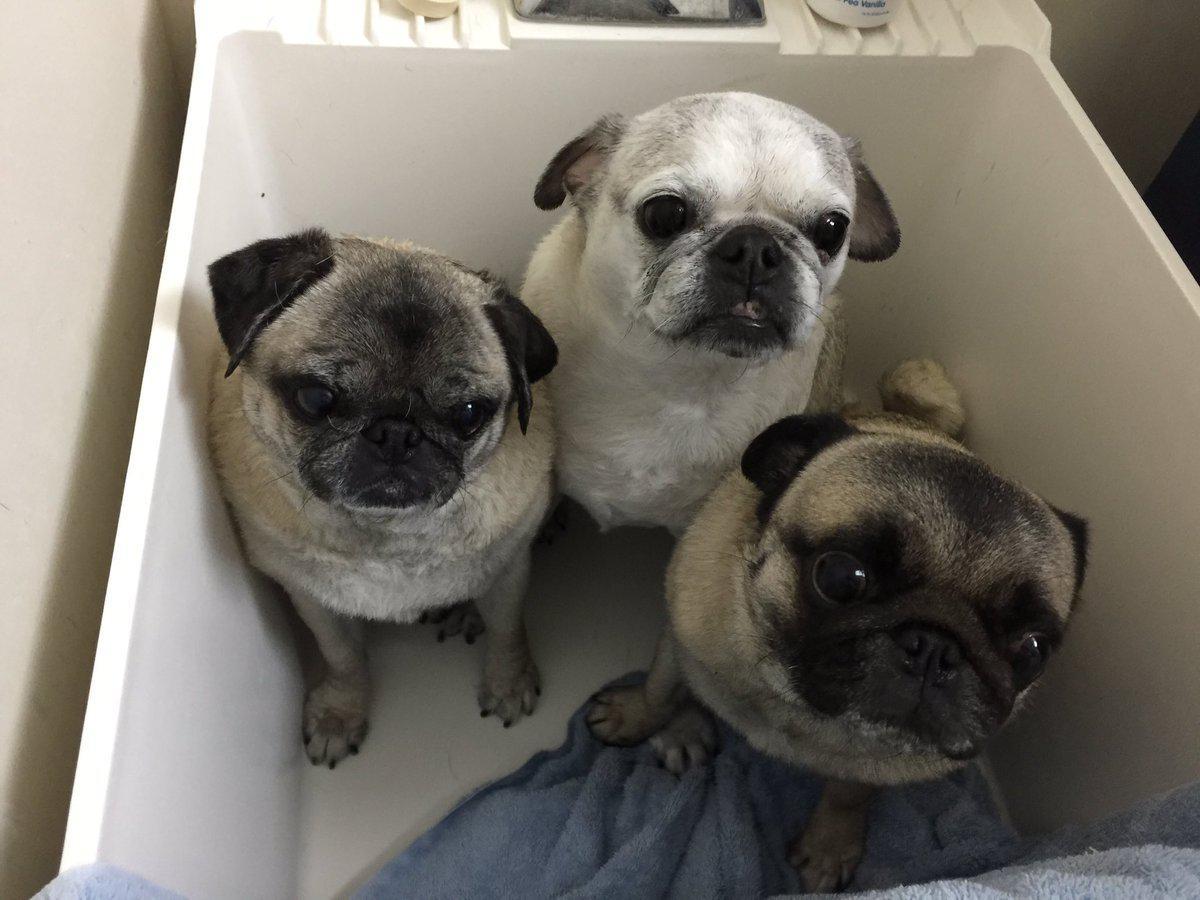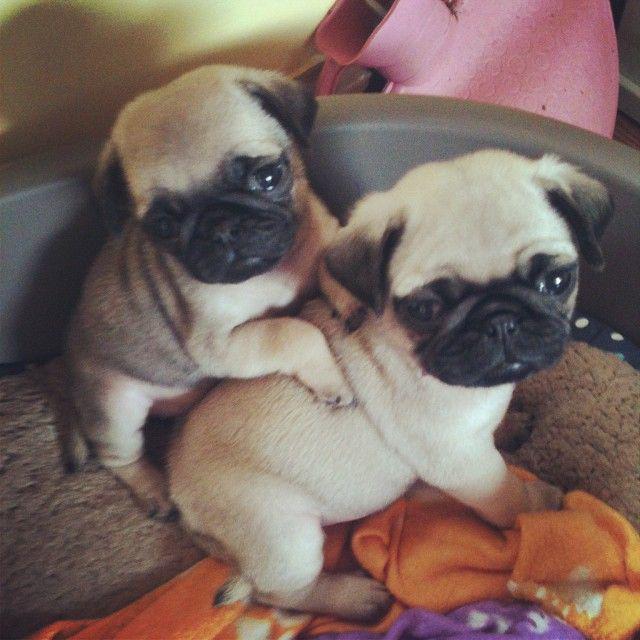The first image is the image on the left, the second image is the image on the right. Considering the images on both sides, is "There are two puppies visible in the image on the right" valid? Answer yes or no. Yes. The first image is the image on the left, the second image is the image on the right. Analyze the images presented: Is the assertion "There is two pugs in the right image." valid? Answer yes or no. Yes. 